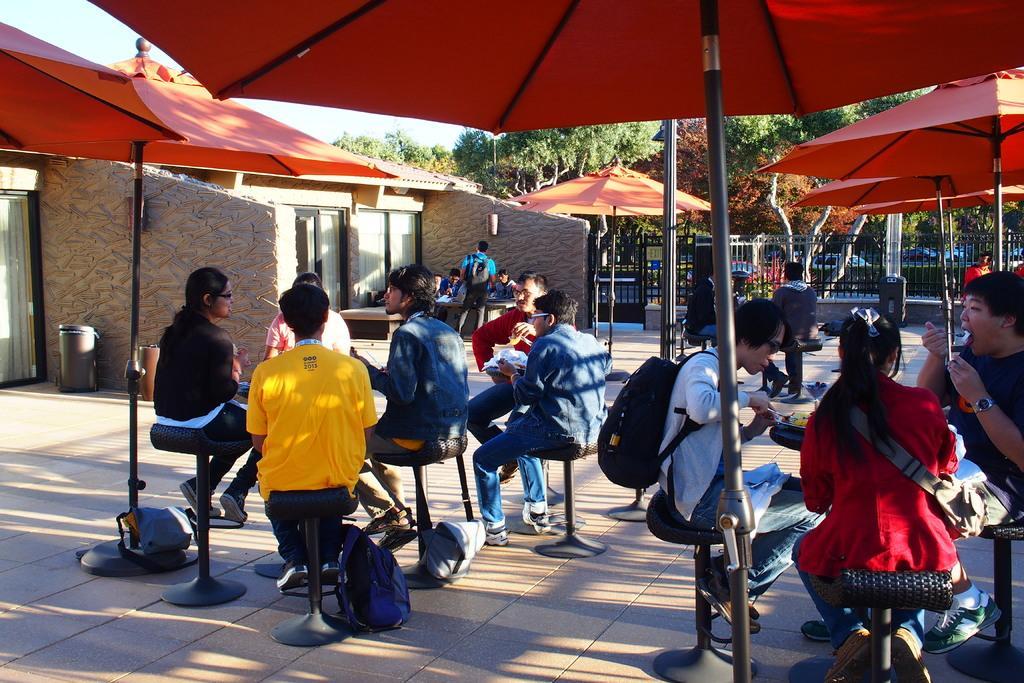How would you summarize this image in a sentence or two? In the foreground of this image, there are people sitting on the chairs under the umbrellas. We can also see few bags on the ground. On the left, there is wall, roof and few dustbins. In the background, there are trees, grill and the sky. 